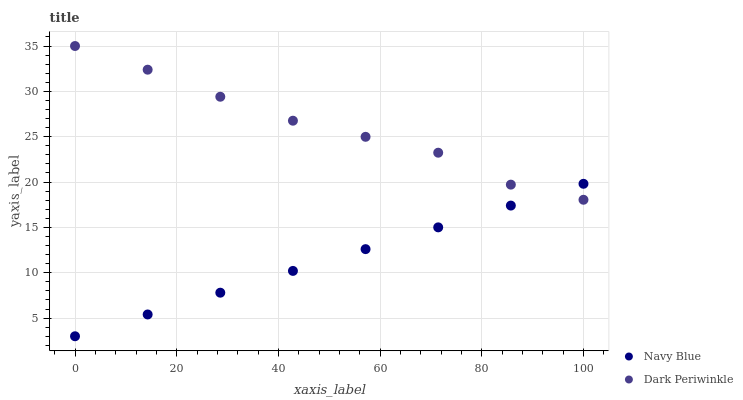Does Navy Blue have the minimum area under the curve?
Answer yes or no. Yes. Does Dark Periwinkle have the maximum area under the curve?
Answer yes or no. Yes. Does Dark Periwinkle have the minimum area under the curve?
Answer yes or no. No. Is Navy Blue the smoothest?
Answer yes or no. Yes. Is Dark Periwinkle the roughest?
Answer yes or no. Yes. Is Dark Periwinkle the smoothest?
Answer yes or no. No. Does Navy Blue have the lowest value?
Answer yes or no. Yes. Does Dark Periwinkle have the lowest value?
Answer yes or no. No. Does Dark Periwinkle have the highest value?
Answer yes or no. Yes. Does Dark Periwinkle intersect Navy Blue?
Answer yes or no. Yes. Is Dark Periwinkle less than Navy Blue?
Answer yes or no. No. Is Dark Periwinkle greater than Navy Blue?
Answer yes or no. No. 